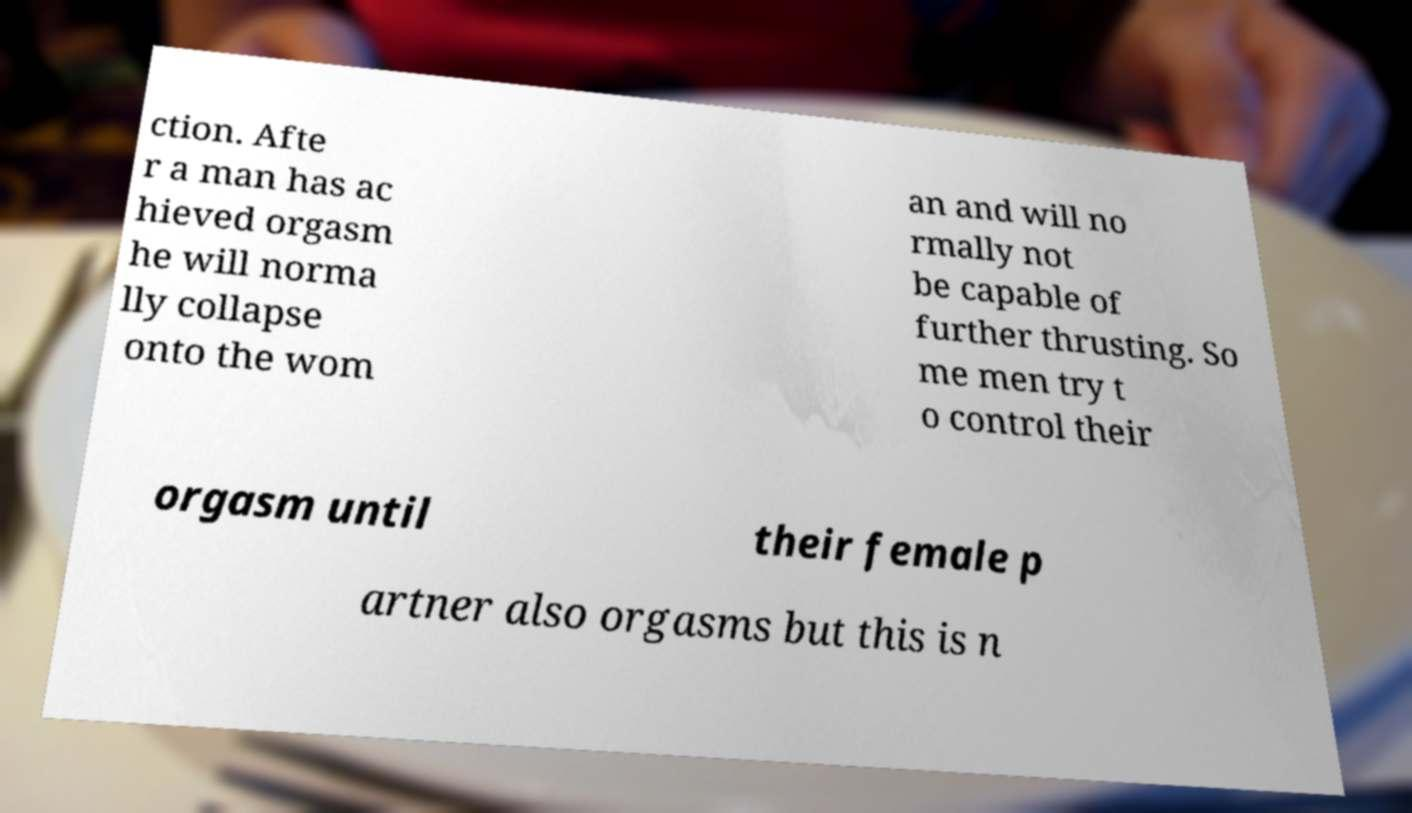Could you extract and type out the text from this image? ction. Afte r a man has ac hieved orgasm he will norma lly collapse onto the wom an and will no rmally not be capable of further thrusting. So me men try t o control their orgasm until their female p artner also orgasms but this is n 